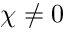<formula> <loc_0><loc_0><loc_500><loc_500>\chi \neq 0</formula> 